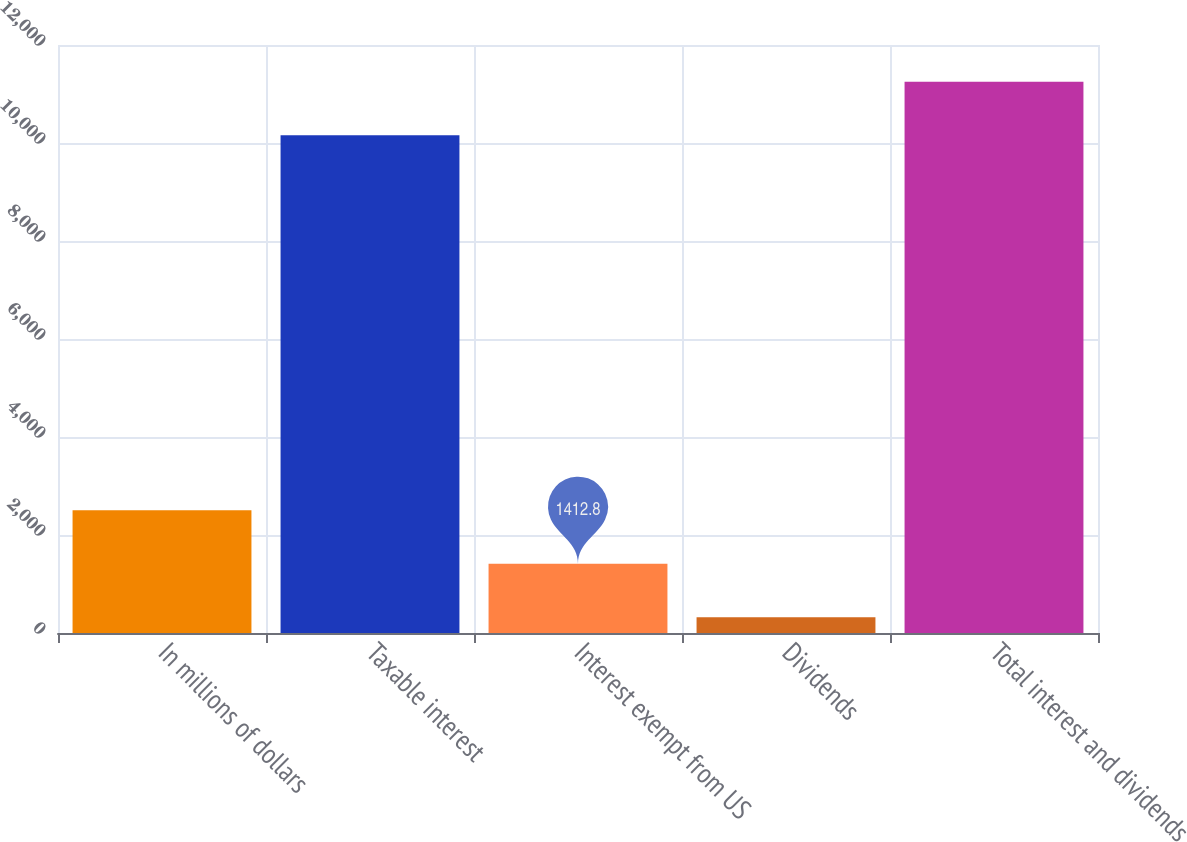Convert chart. <chart><loc_0><loc_0><loc_500><loc_500><bar_chart><fcel>In millions of dollars<fcel>Taxable interest<fcel>Interest exempt from US<fcel>Dividends<fcel>Total interest and dividends<nl><fcel>2504.6<fcel>10160<fcel>1412.8<fcel>321<fcel>11251.8<nl></chart> 